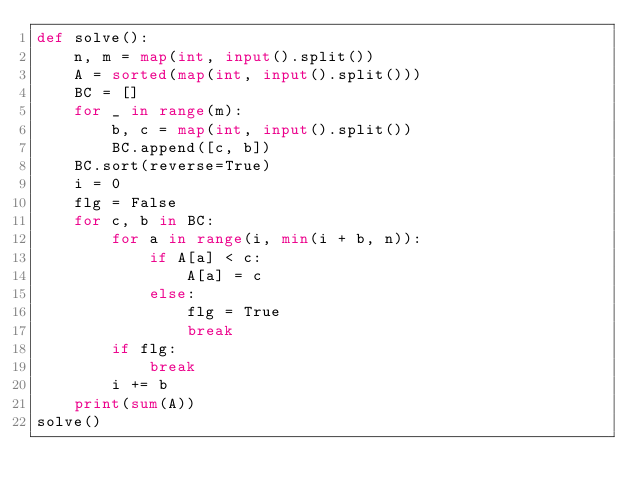<code> <loc_0><loc_0><loc_500><loc_500><_Python_>def solve():
    n, m = map(int, input().split())
    A = sorted(map(int, input().split()))
    BC = []
    for _ in range(m):
        b, c = map(int, input().split())
        BC.append([c, b])
    BC.sort(reverse=True)
    i = 0
    flg = False
    for c, b in BC:
        for a in range(i, min(i + b, n)):
            if A[a] < c:
                A[a] = c
            else:
                flg = True
                break
        if flg:
            break
        i += b
    print(sum(A))
solve()
</code> 